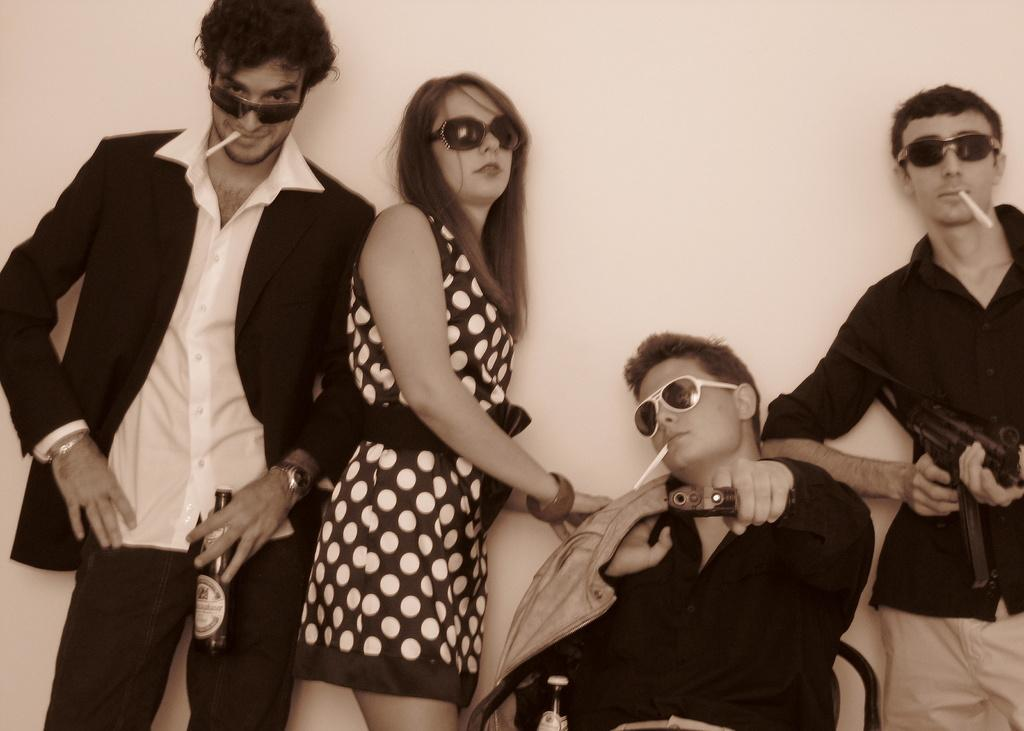How many people are in the image? There are four people in the image. What are the people wearing on their faces? All four people are wearing goggles. What is the position of one of the people in the image? One person is sitting on a chair. What are three of the people doing with the rolled paper? Three people are holding rolled paper in their mouths. What can be seen near the people in the image? There are bottles visible in the image. What is present in the background of the image? There is a wall in the image. What type of engine can be seen in the image? There is no engine present in the image. What is the sponge used for in the image? There is no sponge present in the image. 